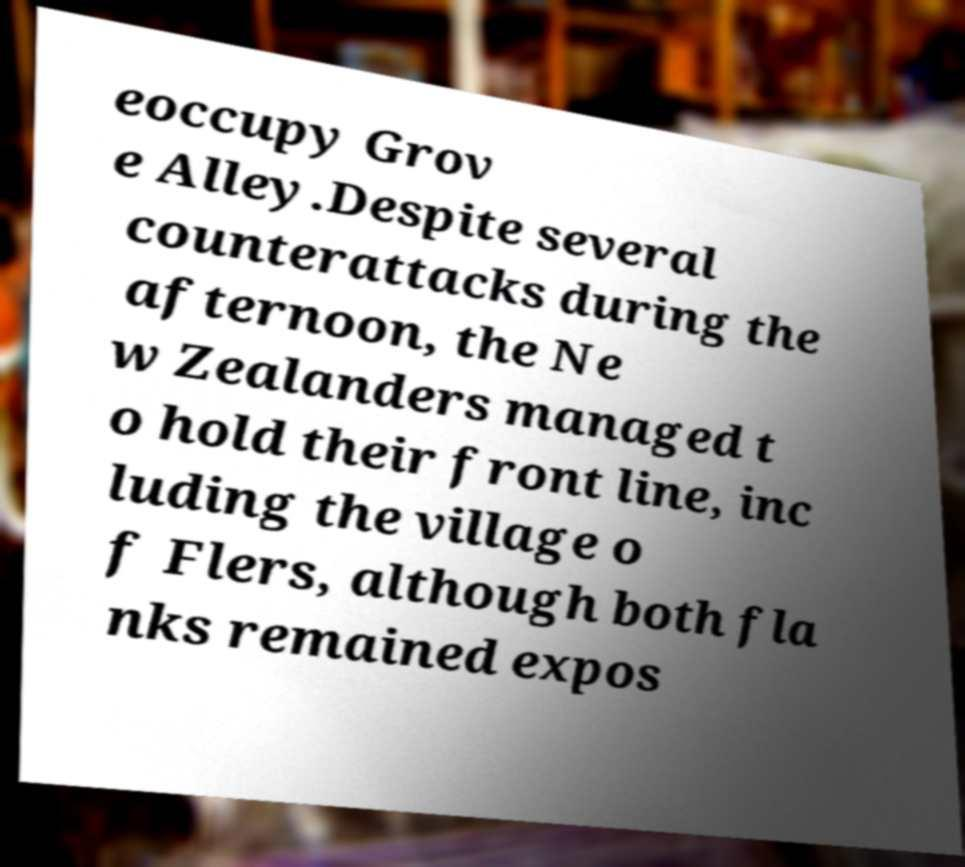For documentation purposes, I need the text within this image transcribed. Could you provide that? eoccupy Grov e Alley.Despite several counterattacks during the afternoon, the Ne w Zealanders managed t o hold their front line, inc luding the village o f Flers, although both fla nks remained expos 